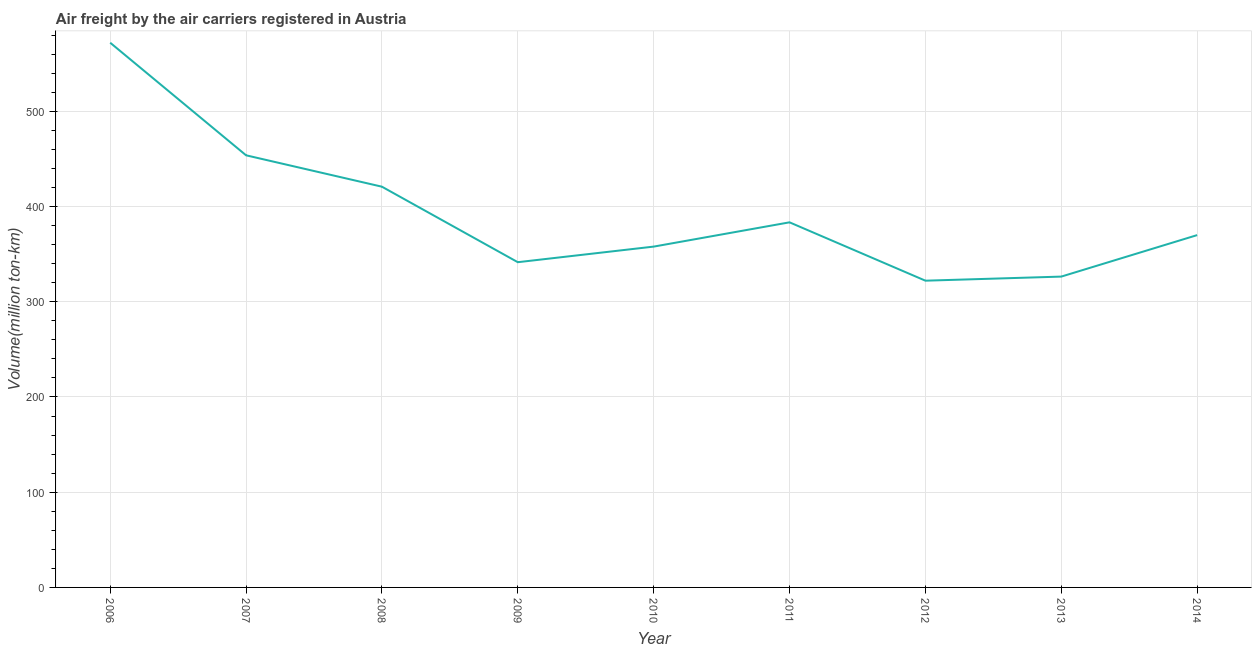What is the air freight in 2012?
Provide a short and direct response. 322.1. Across all years, what is the maximum air freight?
Offer a terse response. 571.98. Across all years, what is the minimum air freight?
Your answer should be compact. 322.1. What is the sum of the air freight?
Offer a very short reply. 3547.76. What is the difference between the air freight in 2008 and 2010?
Offer a very short reply. 62.91. What is the average air freight per year?
Offer a terse response. 394.19. What is the median air freight?
Provide a succinct answer. 369.95. In how many years, is the air freight greater than 200 million ton-km?
Ensure brevity in your answer.  9. What is the ratio of the air freight in 2009 to that in 2010?
Make the answer very short. 0.95. Is the difference between the air freight in 2007 and 2012 greater than the difference between any two years?
Your response must be concise. No. What is the difference between the highest and the second highest air freight?
Your response must be concise. 118.22. What is the difference between the highest and the lowest air freight?
Keep it short and to the point. 249.87. In how many years, is the air freight greater than the average air freight taken over all years?
Offer a very short reply. 3. Does the air freight monotonically increase over the years?
Provide a short and direct response. No. How many lines are there?
Keep it short and to the point. 1. How many years are there in the graph?
Your answer should be compact. 9. What is the difference between two consecutive major ticks on the Y-axis?
Give a very brief answer. 100. What is the title of the graph?
Ensure brevity in your answer.  Air freight by the air carriers registered in Austria. What is the label or title of the X-axis?
Ensure brevity in your answer.  Year. What is the label or title of the Y-axis?
Your answer should be compact. Volume(million ton-km). What is the Volume(million ton-km) in 2006?
Provide a succinct answer. 571.98. What is the Volume(million ton-km) of 2007?
Your answer should be very brief. 453.76. What is the Volume(million ton-km) in 2008?
Make the answer very short. 420.79. What is the Volume(million ton-km) of 2009?
Make the answer very short. 341.51. What is the Volume(million ton-km) of 2010?
Your answer should be compact. 357.88. What is the Volume(million ton-km) in 2011?
Offer a terse response. 383.37. What is the Volume(million ton-km) of 2012?
Offer a terse response. 322.1. What is the Volume(million ton-km) in 2013?
Your answer should be very brief. 326.4. What is the Volume(million ton-km) of 2014?
Your answer should be compact. 369.95. What is the difference between the Volume(million ton-km) in 2006 and 2007?
Give a very brief answer. 118.22. What is the difference between the Volume(million ton-km) in 2006 and 2008?
Give a very brief answer. 151.18. What is the difference between the Volume(million ton-km) in 2006 and 2009?
Make the answer very short. 230.47. What is the difference between the Volume(million ton-km) in 2006 and 2010?
Give a very brief answer. 214.09. What is the difference between the Volume(million ton-km) in 2006 and 2011?
Your response must be concise. 188.61. What is the difference between the Volume(million ton-km) in 2006 and 2012?
Your answer should be compact. 249.87. What is the difference between the Volume(million ton-km) in 2006 and 2013?
Give a very brief answer. 245.58. What is the difference between the Volume(million ton-km) in 2006 and 2014?
Keep it short and to the point. 202.02. What is the difference between the Volume(million ton-km) in 2007 and 2008?
Offer a very short reply. 32.97. What is the difference between the Volume(million ton-km) in 2007 and 2009?
Your answer should be compact. 112.25. What is the difference between the Volume(million ton-km) in 2007 and 2010?
Provide a succinct answer. 95.87. What is the difference between the Volume(million ton-km) in 2007 and 2011?
Your answer should be very brief. 70.39. What is the difference between the Volume(million ton-km) in 2007 and 2012?
Provide a short and direct response. 131.66. What is the difference between the Volume(million ton-km) in 2007 and 2013?
Make the answer very short. 127.36. What is the difference between the Volume(million ton-km) in 2007 and 2014?
Ensure brevity in your answer.  83.8. What is the difference between the Volume(million ton-km) in 2008 and 2009?
Your answer should be very brief. 79.28. What is the difference between the Volume(million ton-km) in 2008 and 2010?
Make the answer very short. 62.91. What is the difference between the Volume(million ton-km) in 2008 and 2011?
Provide a short and direct response. 37.42. What is the difference between the Volume(million ton-km) in 2008 and 2012?
Your answer should be very brief. 98.69. What is the difference between the Volume(million ton-km) in 2008 and 2013?
Provide a short and direct response. 94.39. What is the difference between the Volume(million ton-km) in 2008 and 2014?
Your response must be concise. 50.84. What is the difference between the Volume(million ton-km) in 2009 and 2010?
Provide a short and direct response. -16.37. What is the difference between the Volume(million ton-km) in 2009 and 2011?
Your response must be concise. -41.86. What is the difference between the Volume(million ton-km) in 2009 and 2012?
Give a very brief answer. 19.41. What is the difference between the Volume(million ton-km) in 2009 and 2013?
Keep it short and to the point. 15.11. What is the difference between the Volume(million ton-km) in 2009 and 2014?
Provide a succinct answer. -28.44. What is the difference between the Volume(million ton-km) in 2010 and 2011?
Your answer should be compact. -25.49. What is the difference between the Volume(million ton-km) in 2010 and 2012?
Give a very brief answer. 35.78. What is the difference between the Volume(million ton-km) in 2010 and 2013?
Make the answer very short. 31.49. What is the difference between the Volume(million ton-km) in 2010 and 2014?
Make the answer very short. -12.07. What is the difference between the Volume(million ton-km) in 2011 and 2012?
Your answer should be compact. 61.27. What is the difference between the Volume(million ton-km) in 2011 and 2013?
Your response must be concise. 56.97. What is the difference between the Volume(million ton-km) in 2011 and 2014?
Keep it short and to the point. 13.42. What is the difference between the Volume(million ton-km) in 2012 and 2013?
Provide a short and direct response. -4.29. What is the difference between the Volume(million ton-km) in 2012 and 2014?
Your answer should be compact. -47.85. What is the difference between the Volume(million ton-km) in 2013 and 2014?
Offer a very short reply. -43.56. What is the ratio of the Volume(million ton-km) in 2006 to that in 2007?
Provide a succinct answer. 1.26. What is the ratio of the Volume(million ton-km) in 2006 to that in 2008?
Offer a terse response. 1.36. What is the ratio of the Volume(million ton-km) in 2006 to that in 2009?
Give a very brief answer. 1.68. What is the ratio of the Volume(million ton-km) in 2006 to that in 2010?
Offer a very short reply. 1.6. What is the ratio of the Volume(million ton-km) in 2006 to that in 2011?
Offer a very short reply. 1.49. What is the ratio of the Volume(million ton-km) in 2006 to that in 2012?
Give a very brief answer. 1.78. What is the ratio of the Volume(million ton-km) in 2006 to that in 2013?
Provide a succinct answer. 1.75. What is the ratio of the Volume(million ton-km) in 2006 to that in 2014?
Keep it short and to the point. 1.55. What is the ratio of the Volume(million ton-km) in 2007 to that in 2008?
Give a very brief answer. 1.08. What is the ratio of the Volume(million ton-km) in 2007 to that in 2009?
Your answer should be very brief. 1.33. What is the ratio of the Volume(million ton-km) in 2007 to that in 2010?
Your answer should be compact. 1.27. What is the ratio of the Volume(million ton-km) in 2007 to that in 2011?
Make the answer very short. 1.18. What is the ratio of the Volume(million ton-km) in 2007 to that in 2012?
Your answer should be compact. 1.41. What is the ratio of the Volume(million ton-km) in 2007 to that in 2013?
Your response must be concise. 1.39. What is the ratio of the Volume(million ton-km) in 2007 to that in 2014?
Your answer should be very brief. 1.23. What is the ratio of the Volume(million ton-km) in 2008 to that in 2009?
Provide a succinct answer. 1.23. What is the ratio of the Volume(million ton-km) in 2008 to that in 2010?
Offer a terse response. 1.18. What is the ratio of the Volume(million ton-km) in 2008 to that in 2011?
Your answer should be compact. 1.1. What is the ratio of the Volume(million ton-km) in 2008 to that in 2012?
Offer a very short reply. 1.31. What is the ratio of the Volume(million ton-km) in 2008 to that in 2013?
Offer a terse response. 1.29. What is the ratio of the Volume(million ton-km) in 2008 to that in 2014?
Your answer should be very brief. 1.14. What is the ratio of the Volume(million ton-km) in 2009 to that in 2010?
Your answer should be compact. 0.95. What is the ratio of the Volume(million ton-km) in 2009 to that in 2011?
Provide a short and direct response. 0.89. What is the ratio of the Volume(million ton-km) in 2009 to that in 2012?
Your answer should be very brief. 1.06. What is the ratio of the Volume(million ton-km) in 2009 to that in 2013?
Offer a terse response. 1.05. What is the ratio of the Volume(million ton-km) in 2009 to that in 2014?
Your answer should be very brief. 0.92. What is the ratio of the Volume(million ton-km) in 2010 to that in 2011?
Make the answer very short. 0.93. What is the ratio of the Volume(million ton-km) in 2010 to that in 2012?
Your answer should be compact. 1.11. What is the ratio of the Volume(million ton-km) in 2010 to that in 2013?
Your response must be concise. 1.1. What is the ratio of the Volume(million ton-km) in 2010 to that in 2014?
Your answer should be very brief. 0.97. What is the ratio of the Volume(million ton-km) in 2011 to that in 2012?
Provide a succinct answer. 1.19. What is the ratio of the Volume(million ton-km) in 2011 to that in 2013?
Provide a succinct answer. 1.18. What is the ratio of the Volume(million ton-km) in 2011 to that in 2014?
Your answer should be very brief. 1.04. What is the ratio of the Volume(million ton-km) in 2012 to that in 2013?
Offer a very short reply. 0.99. What is the ratio of the Volume(million ton-km) in 2012 to that in 2014?
Ensure brevity in your answer.  0.87. What is the ratio of the Volume(million ton-km) in 2013 to that in 2014?
Offer a very short reply. 0.88. 